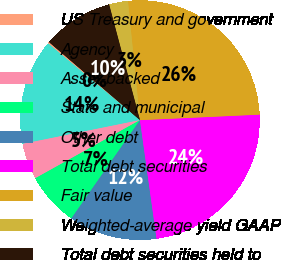<chart> <loc_0><loc_0><loc_500><loc_500><pie_chart><fcel>US Treasury and government<fcel>Agency<fcel>Asset-backed<fcel>State and municipal<fcel>Other debt<fcel>Total debt securities<fcel>Fair value<fcel>Weighted-average yield GAAP<fcel>Total debt securities held to<nl><fcel>0.2%<fcel>14.26%<fcel>4.89%<fcel>7.23%<fcel>11.91%<fcel>23.52%<fcel>25.86%<fcel>2.55%<fcel>9.57%<nl></chart> 